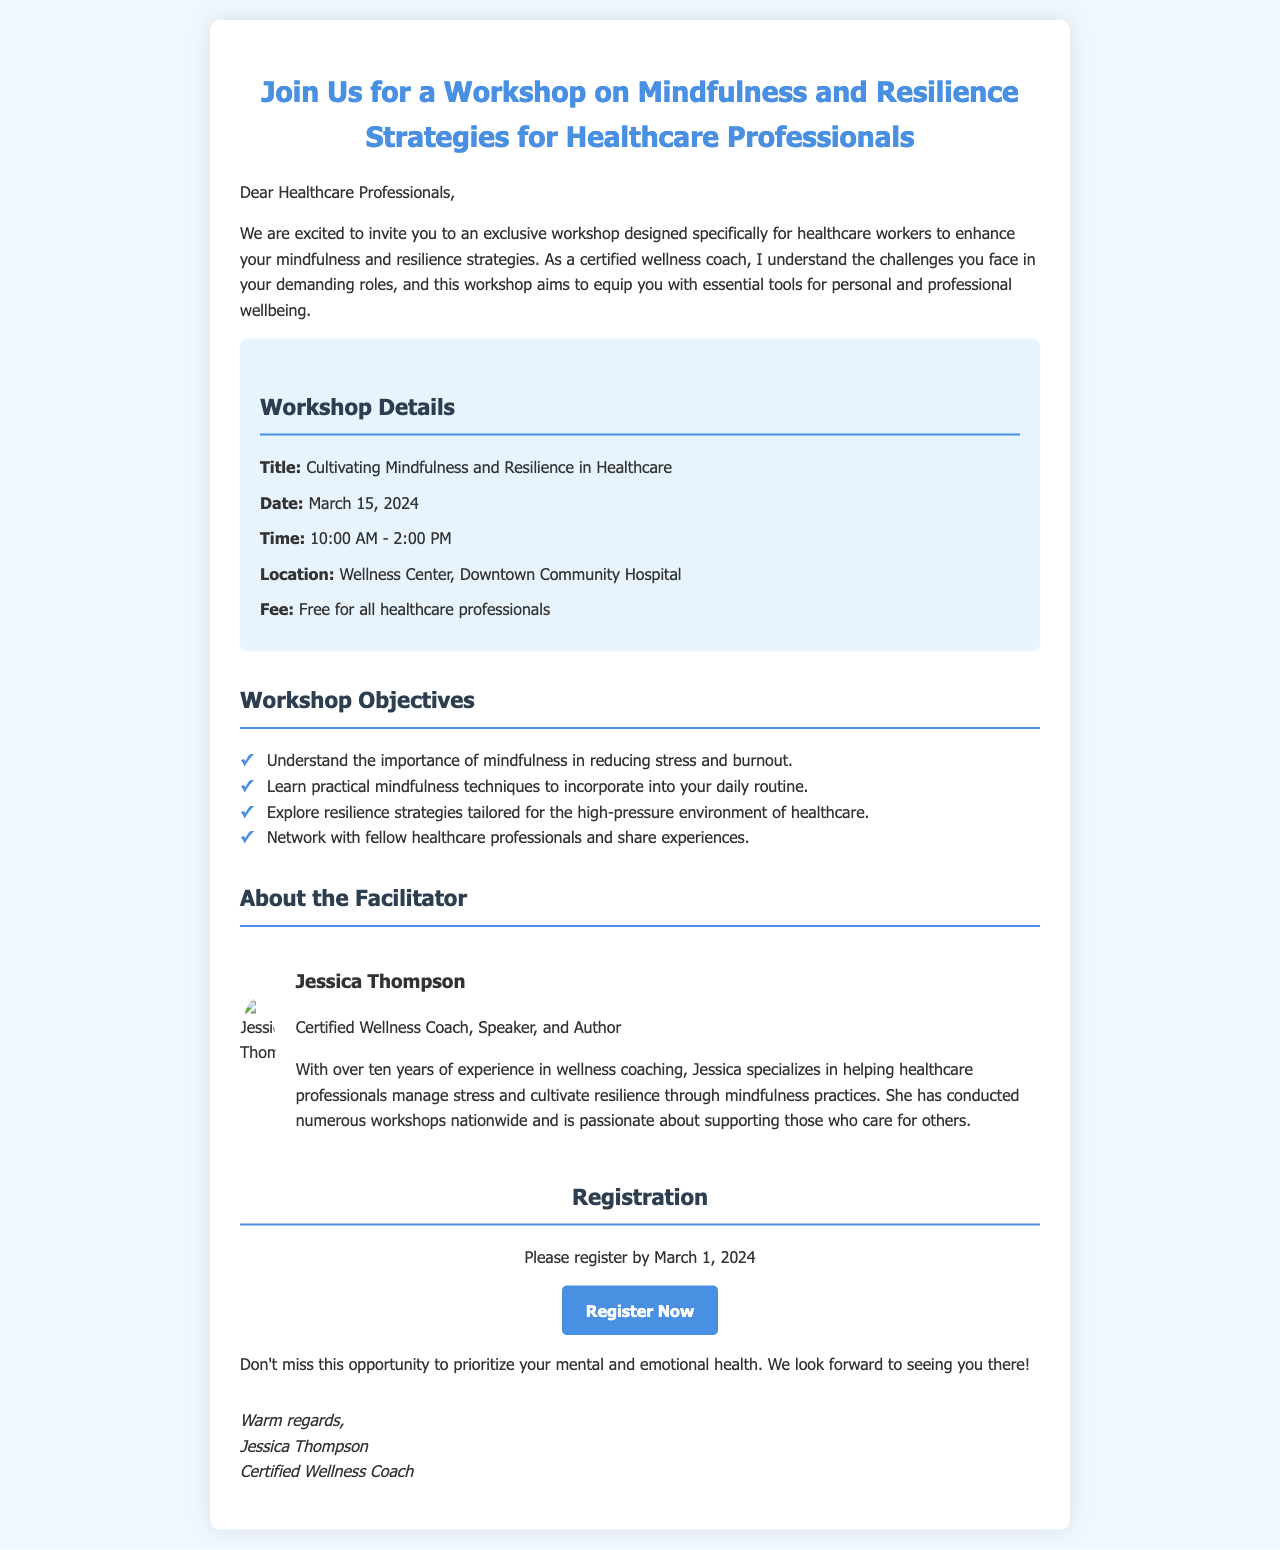what is the title of the workshop? The title of the workshop is explicitly mentioned in the document as "Cultivating Mindfulness and Resilience in Healthcare."
Answer: Cultivating Mindfulness and Resilience in Healthcare what is the date of the workshop? The date of the workshop is clearly stated in the document as March 15, 2024.
Answer: March 15, 2024 who is the facilitator of the workshop? The facilitator's name, as outlined in the document, is Jessica Thompson.
Answer: Jessica Thompson what is the fee for attending the workshop? The document indicates that the fee is free for healthcare professionals.
Answer: Free what are the workshop hours? The workshop hours are provided in the document as 10:00 AM - 2:00 PM.
Answer: 10:00 AM - 2:00 PM what is the registration deadline? The registration deadline is mentioned as March 1, 2024, in the document.
Answer: March 1, 2024 how long has the facilitator been a wellness coach? The document notes that Jessica Thompson has over ten years of experience as a wellness coach.
Answer: Over ten years what is one objective of the workshop? The document lists several objectives; one of them is to "learn practical mindfulness techniques to incorporate into your daily routine."
Answer: Learn practical mindfulness techniques to incorporate into your daily routine where will the workshop take place? The location of the workshop is stated as "Wellness Center, Downtown Community Hospital" in the document.
Answer: Wellness Center, Downtown Community Hospital 